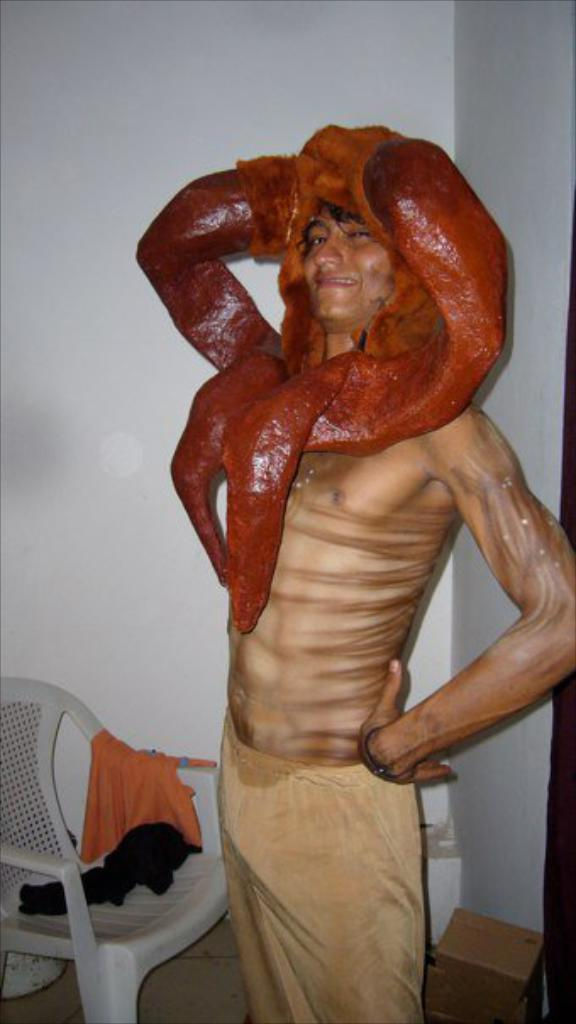What is the main subject of the image? There is a person in the image. What is the person wearing? The person is wearing a fancy dress. What is located behind the person? There is a chair behind the person. What color is the wall in the image? The wall is white in color. How many apples are on the person's head in the image? There are no apples present in the image. What type of payment is being made in the image? There is no payment being made in the image. 